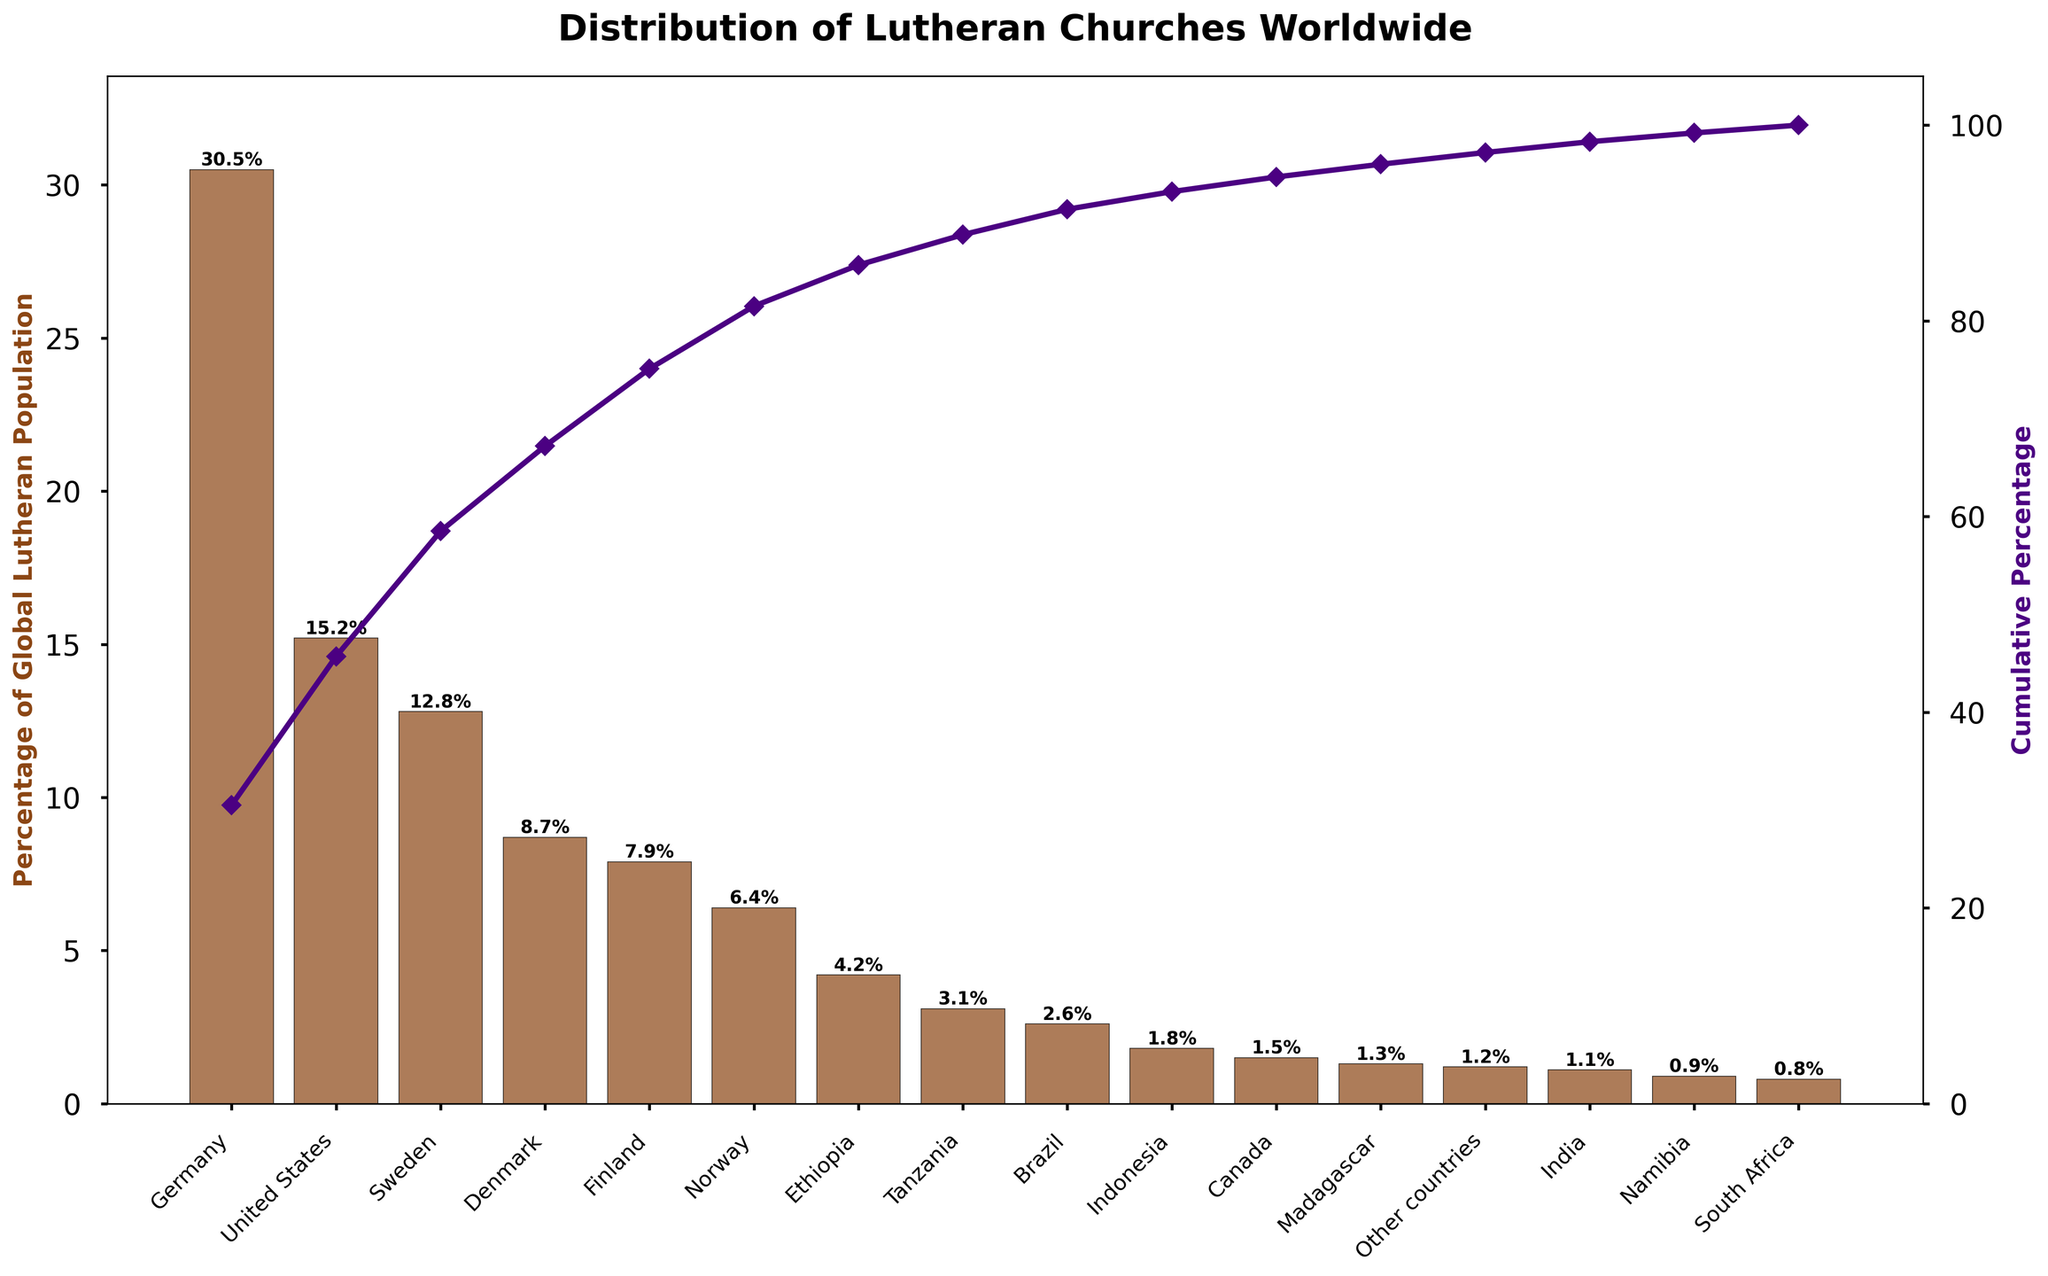What is the title of the chart? The title of the chart is displayed at the top and tells us what the entire chart represents. In this case, the title is "Distribution of Lutheran Churches Worldwide."
Answer: Distribution of Lutheran Churches Worldwide Which country has the highest percentage of the global Lutheran population? The bar representing Germany is the highest in the chart, indicating that it has the highest percentage of the global Lutheran population.
Answer: Germany What is the cumulative percentage of the Lutheran population covered by Germany, the United States, and Sweden? To find the cumulative percentage, add the individual percentages of these countries: Germany (30.5) + United States (15.2) + Sweden (12.8).
Answer: 58.5% How much higher is the percentage of the Lutheran population in Germany compared to Indonesia? Subtract the percentage of Indonesia from Germany: 30.5% - 1.8%.
Answer: 28.7% Which two countries have roughly the same percentage of the global Lutheran population? Comparing the bars, Finland (7.9%) and Norway (6.4%) have relatively close percentages.
Answer: Finland and Norway What is the cumulative percentage after including the first five countries? Add the percentages of the first five countries: Germany (30.5), United States (15.2), Sweden (12.8), Denmark (8.7), and Finland (7.9).
Answer: 75.1% If you combined the percentages of Ethiopia and Tanzania, where would this new percentage rank among the listed countries? Add the percentages: Ethiopia (4.2) + Tanzania (3.1) = 7.3%. This would rank just below Finland (7.9%) and above Norway (6.4%).
Answer: Seventh Which country marks the point where the cumulative percentage first exceeds 50%? When summing the percentages, the cumulative percentage exceeds 50% after adding Sweden's 12.8% to Germany's 30.5% and United States' 15.2%.
Answer: Sweden Among the African countries listed, which has the highest percentage of the global Lutheran population? Comparing Ethiopia (4.2%), Tanzania (3.1%), Madagascar (1.3%), Namibia (0.9%), and South Africa (0.8%), Ethiopia has the highest percentage.
Answer: Ethiopia What is the total percentage of the global Lutheran population accounted for by the "Other countries" category? The "Other countries" category is explicitly listed with a percentage.
Answer: 1.2% 